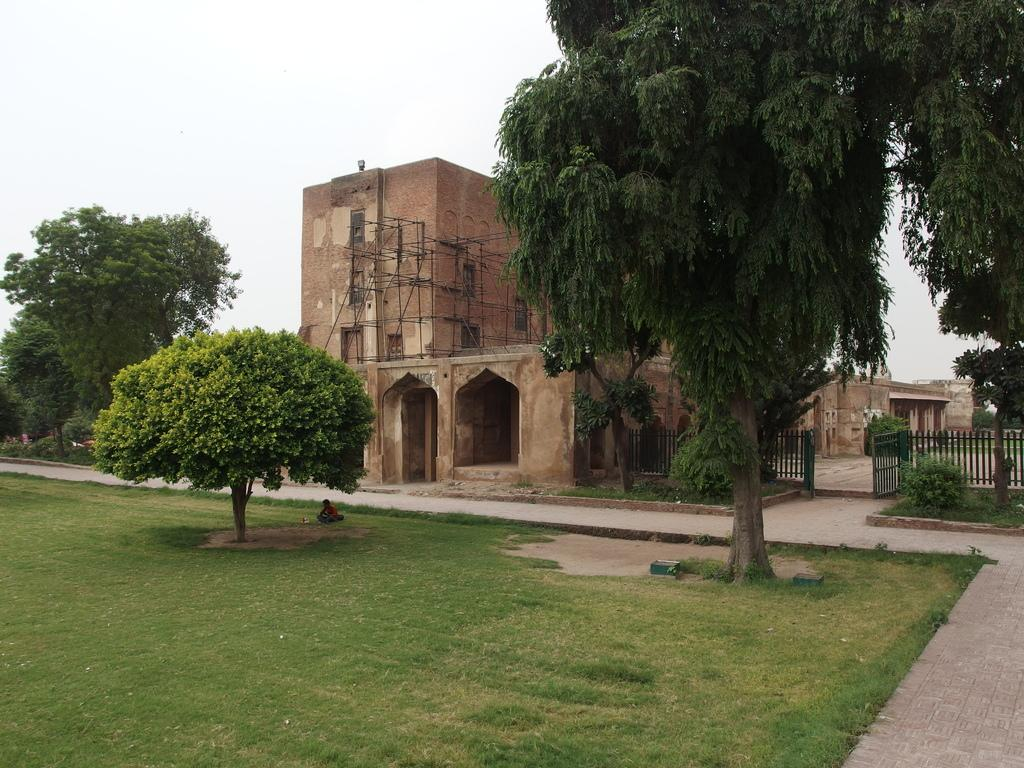What type of vegetation is present in the image? There is grass in the image. What other natural elements can be seen in the image? There are trees in the image. What type of structure is present in the image? There is a fence in the image. Are there any human figures in the image? Yes, there is a person in the image. What type of man-made structures are visible in the image? There are buildings in the image. What part of the natural environment is visible in the image? The sky is visible at the top of the image. Based on the presence of the sky and the absence of artificial lighting, can we infer the time of day the image was taken? Yes, the image is likely taken during the day. What plot of land does the person's dad own in the image? There is no information about the person's dad or any plot of land in the image. How does the person wash their hands in the image? There is no indication of handwashing or any water source in the image. 